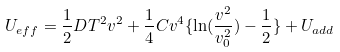Convert formula to latex. <formula><loc_0><loc_0><loc_500><loc_500>U _ { e f f } = \frac { 1 } { 2 } D T ^ { 2 } v ^ { 2 } + \frac { 1 } { 4 } C v ^ { 4 } \{ \ln ( \frac { v ^ { 2 } } { v ^ { 2 } _ { 0 } } ) - \frac { 1 } { 2 } \} + U _ { a d d }</formula> 